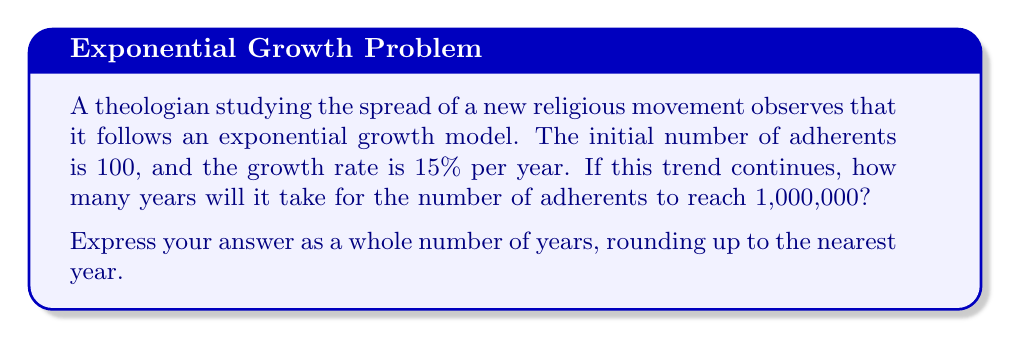Help me with this question. To solve this problem, we'll use the exponential growth function:

$$A(t) = A_0 \cdot (1 + r)^t$$

Where:
$A(t)$ is the number of adherents after $t$ years
$A_0$ is the initial number of adherents
$r$ is the growth rate (as a decimal)
$t$ is the time in years

We're given:
$A_0 = 100$
$r = 0.15$ (15% expressed as a decimal)
$A(t) = 1,000,000$ (the target number of adherents)

Let's substitute these values into the equation:

$$1,000,000 = 100 \cdot (1 + 0.15)^t$$

To solve for $t$, we'll use logarithms:

1) First, divide both sides by 100:
   $$10,000 = (1.15)^t$$

2) Take the natural log of both sides:
   $$\ln(10,000) = \ln((1.15)^t)$$

3) Use the logarithm property $\ln(a^b) = b\ln(a)$:
   $$\ln(10,000) = t \cdot \ln(1.15)$$

4) Solve for $t$:
   $$t = \frac{\ln(10,000)}{\ln(1.15)}$$

5) Calculate the result:
   $$t \approx 32.36$$

Since we need to round up to the nearest year, the final answer is 33 years.
Answer: 33 years 